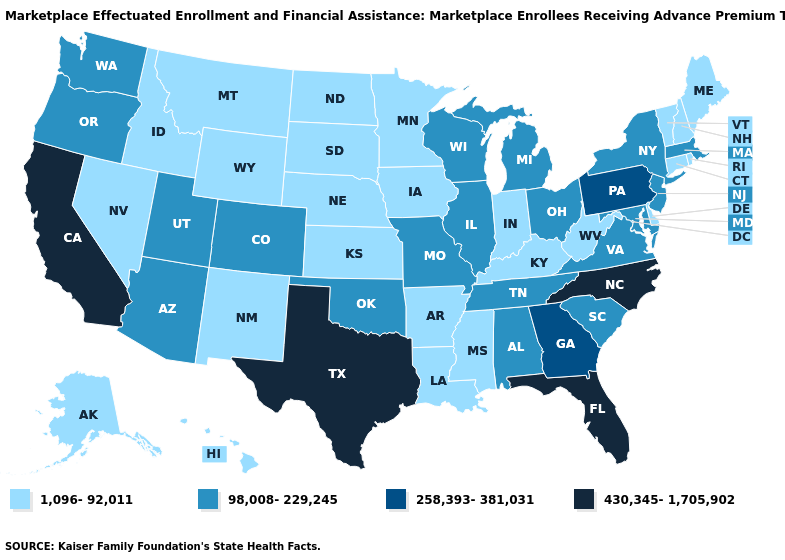Does Wyoming have a lower value than South Carolina?
Answer briefly. Yes. Does Minnesota have the lowest value in the MidWest?
Answer briefly. Yes. Does Arkansas have the same value as New York?
Be succinct. No. Does New Mexico have a lower value than Connecticut?
Be succinct. No. Name the states that have a value in the range 430,345-1,705,902?
Answer briefly. California, Florida, North Carolina, Texas. Does the map have missing data?
Answer briefly. No. Name the states that have a value in the range 430,345-1,705,902?
Answer briefly. California, Florida, North Carolina, Texas. Among the states that border Colorado , does Oklahoma have the lowest value?
Give a very brief answer. No. Name the states that have a value in the range 1,096-92,011?
Quick response, please. Alaska, Arkansas, Connecticut, Delaware, Hawaii, Idaho, Indiana, Iowa, Kansas, Kentucky, Louisiana, Maine, Minnesota, Mississippi, Montana, Nebraska, Nevada, New Hampshire, New Mexico, North Dakota, Rhode Island, South Dakota, Vermont, West Virginia, Wyoming. What is the value of Indiana?
Quick response, please. 1,096-92,011. What is the value of Missouri?
Answer briefly. 98,008-229,245. Name the states that have a value in the range 1,096-92,011?
Be succinct. Alaska, Arkansas, Connecticut, Delaware, Hawaii, Idaho, Indiana, Iowa, Kansas, Kentucky, Louisiana, Maine, Minnesota, Mississippi, Montana, Nebraska, Nevada, New Hampshire, New Mexico, North Dakota, Rhode Island, South Dakota, Vermont, West Virginia, Wyoming. Does Virginia have a higher value than West Virginia?
Quick response, please. Yes. What is the value of Massachusetts?
Concise answer only. 98,008-229,245. What is the value of Florida?
Keep it brief. 430,345-1,705,902. 